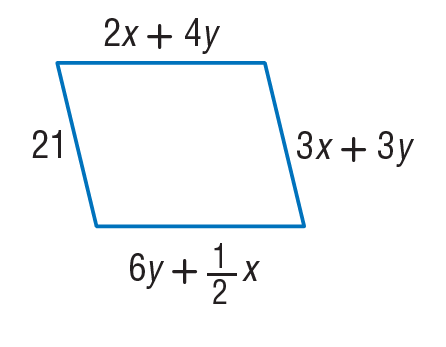Question: Find x so that the quadrilateral is a parallelogram.
Choices:
A. 4
B. 6
C. 8
D. 12
Answer with the letter. Answer: A Question: Find y so that the quadrilateral is a parallelogram.
Choices:
A. 3
B. 6
C. 9
D. 12
Answer with the letter. Answer: A 